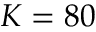Convert formula to latex. <formula><loc_0><loc_0><loc_500><loc_500>K = 8 0</formula> 